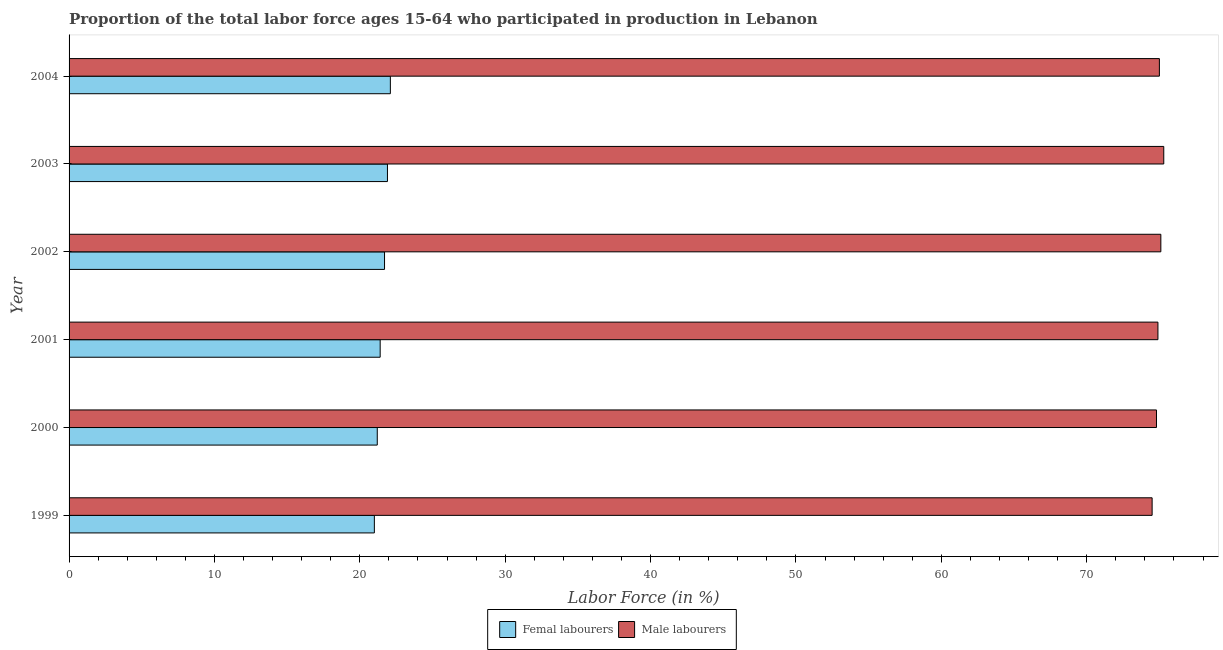How many different coloured bars are there?
Offer a very short reply. 2. How many groups of bars are there?
Give a very brief answer. 6. Are the number of bars on each tick of the Y-axis equal?
Keep it short and to the point. Yes. What is the label of the 6th group of bars from the top?
Make the answer very short. 1999. What is the percentage of female labor force in 2002?
Make the answer very short. 21.7. Across all years, what is the maximum percentage of male labour force?
Your answer should be compact. 75.3. Across all years, what is the minimum percentage of male labour force?
Give a very brief answer. 74.5. What is the total percentage of female labor force in the graph?
Your answer should be very brief. 129.3. What is the difference between the percentage of female labor force in 1999 and that in 2001?
Your answer should be compact. -0.4. What is the difference between the percentage of male labour force in 2000 and the percentage of female labor force in 2003?
Give a very brief answer. 52.9. What is the average percentage of female labor force per year?
Provide a short and direct response. 21.55. In the year 2002, what is the difference between the percentage of female labor force and percentage of male labour force?
Make the answer very short. -53.4. In how many years, is the percentage of female labor force greater than 74 %?
Offer a very short reply. 0. What is the ratio of the percentage of male labour force in 1999 to that in 2002?
Your answer should be compact. 0.99. What is the difference between the highest and the lowest percentage of male labour force?
Give a very brief answer. 0.8. What does the 2nd bar from the top in 2001 represents?
Provide a short and direct response. Femal labourers. What does the 2nd bar from the bottom in 2003 represents?
Offer a terse response. Male labourers. How many bars are there?
Your answer should be compact. 12. Are all the bars in the graph horizontal?
Ensure brevity in your answer.  Yes. How many years are there in the graph?
Ensure brevity in your answer.  6. Are the values on the major ticks of X-axis written in scientific E-notation?
Make the answer very short. No. Does the graph contain any zero values?
Make the answer very short. No. Does the graph contain grids?
Offer a very short reply. No. How are the legend labels stacked?
Give a very brief answer. Horizontal. What is the title of the graph?
Provide a succinct answer. Proportion of the total labor force ages 15-64 who participated in production in Lebanon. Does "Investment in Transport" appear as one of the legend labels in the graph?
Your answer should be very brief. No. What is the label or title of the X-axis?
Keep it short and to the point. Labor Force (in %). What is the label or title of the Y-axis?
Your answer should be compact. Year. What is the Labor Force (in %) in Femal labourers in 1999?
Your answer should be compact. 21. What is the Labor Force (in %) of Male labourers in 1999?
Make the answer very short. 74.5. What is the Labor Force (in %) in Femal labourers in 2000?
Provide a short and direct response. 21.2. What is the Labor Force (in %) of Male labourers in 2000?
Ensure brevity in your answer.  74.8. What is the Labor Force (in %) in Femal labourers in 2001?
Offer a very short reply. 21.4. What is the Labor Force (in %) of Male labourers in 2001?
Make the answer very short. 74.9. What is the Labor Force (in %) in Femal labourers in 2002?
Your answer should be very brief. 21.7. What is the Labor Force (in %) of Male labourers in 2002?
Your answer should be very brief. 75.1. What is the Labor Force (in %) of Femal labourers in 2003?
Give a very brief answer. 21.9. What is the Labor Force (in %) of Male labourers in 2003?
Your answer should be compact. 75.3. What is the Labor Force (in %) of Femal labourers in 2004?
Provide a short and direct response. 22.1. Across all years, what is the maximum Labor Force (in %) in Femal labourers?
Keep it short and to the point. 22.1. Across all years, what is the maximum Labor Force (in %) of Male labourers?
Give a very brief answer. 75.3. Across all years, what is the minimum Labor Force (in %) in Femal labourers?
Your answer should be very brief. 21. Across all years, what is the minimum Labor Force (in %) in Male labourers?
Provide a succinct answer. 74.5. What is the total Labor Force (in %) in Femal labourers in the graph?
Your answer should be compact. 129.3. What is the total Labor Force (in %) of Male labourers in the graph?
Offer a terse response. 449.6. What is the difference between the Labor Force (in %) in Male labourers in 1999 and that in 2000?
Provide a succinct answer. -0.3. What is the difference between the Labor Force (in %) in Femal labourers in 1999 and that in 2001?
Provide a succinct answer. -0.4. What is the difference between the Labor Force (in %) in Male labourers in 1999 and that in 2001?
Offer a terse response. -0.4. What is the difference between the Labor Force (in %) in Male labourers in 1999 and that in 2002?
Make the answer very short. -0.6. What is the difference between the Labor Force (in %) in Femal labourers in 1999 and that in 2003?
Give a very brief answer. -0.9. What is the difference between the Labor Force (in %) in Femal labourers in 1999 and that in 2004?
Your answer should be compact. -1.1. What is the difference between the Labor Force (in %) in Male labourers in 2000 and that in 2001?
Keep it short and to the point. -0.1. What is the difference between the Labor Force (in %) of Femal labourers in 2000 and that in 2002?
Ensure brevity in your answer.  -0.5. What is the difference between the Labor Force (in %) of Male labourers in 2000 and that in 2002?
Provide a succinct answer. -0.3. What is the difference between the Labor Force (in %) in Femal labourers in 2000 and that in 2004?
Your answer should be compact. -0.9. What is the difference between the Labor Force (in %) of Male labourers in 2000 and that in 2004?
Provide a succinct answer. -0.2. What is the difference between the Labor Force (in %) of Male labourers in 2001 and that in 2002?
Provide a short and direct response. -0.2. What is the difference between the Labor Force (in %) in Male labourers in 2001 and that in 2003?
Provide a short and direct response. -0.4. What is the difference between the Labor Force (in %) in Male labourers in 2001 and that in 2004?
Keep it short and to the point. -0.1. What is the difference between the Labor Force (in %) of Male labourers in 2002 and that in 2003?
Keep it short and to the point. -0.2. What is the difference between the Labor Force (in %) in Femal labourers in 2002 and that in 2004?
Your answer should be compact. -0.4. What is the difference between the Labor Force (in %) of Male labourers in 2002 and that in 2004?
Give a very brief answer. 0.1. What is the difference between the Labor Force (in %) of Male labourers in 2003 and that in 2004?
Provide a succinct answer. 0.3. What is the difference between the Labor Force (in %) in Femal labourers in 1999 and the Labor Force (in %) in Male labourers in 2000?
Provide a succinct answer. -53.8. What is the difference between the Labor Force (in %) of Femal labourers in 1999 and the Labor Force (in %) of Male labourers in 2001?
Provide a short and direct response. -53.9. What is the difference between the Labor Force (in %) in Femal labourers in 1999 and the Labor Force (in %) in Male labourers in 2002?
Provide a succinct answer. -54.1. What is the difference between the Labor Force (in %) in Femal labourers in 1999 and the Labor Force (in %) in Male labourers in 2003?
Offer a very short reply. -54.3. What is the difference between the Labor Force (in %) in Femal labourers in 1999 and the Labor Force (in %) in Male labourers in 2004?
Provide a short and direct response. -54. What is the difference between the Labor Force (in %) in Femal labourers in 2000 and the Labor Force (in %) in Male labourers in 2001?
Provide a succinct answer. -53.7. What is the difference between the Labor Force (in %) of Femal labourers in 2000 and the Labor Force (in %) of Male labourers in 2002?
Your answer should be very brief. -53.9. What is the difference between the Labor Force (in %) in Femal labourers in 2000 and the Labor Force (in %) in Male labourers in 2003?
Keep it short and to the point. -54.1. What is the difference between the Labor Force (in %) in Femal labourers in 2000 and the Labor Force (in %) in Male labourers in 2004?
Offer a terse response. -53.8. What is the difference between the Labor Force (in %) of Femal labourers in 2001 and the Labor Force (in %) of Male labourers in 2002?
Your response must be concise. -53.7. What is the difference between the Labor Force (in %) of Femal labourers in 2001 and the Labor Force (in %) of Male labourers in 2003?
Make the answer very short. -53.9. What is the difference between the Labor Force (in %) of Femal labourers in 2001 and the Labor Force (in %) of Male labourers in 2004?
Provide a short and direct response. -53.6. What is the difference between the Labor Force (in %) of Femal labourers in 2002 and the Labor Force (in %) of Male labourers in 2003?
Offer a very short reply. -53.6. What is the difference between the Labor Force (in %) of Femal labourers in 2002 and the Labor Force (in %) of Male labourers in 2004?
Keep it short and to the point. -53.3. What is the difference between the Labor Force (in %) of Femal labourers in 2003 and the Labor Force (in %) of Male labourers in 2004?
Your answer should be very brief. -53.1. What is the average Labor Force (in %) of Femal labourers per year?
Your answer should be very brief. 21.55. What is the average Labor Force (in %) in Male labourers per year?
Your response must be concise. 74.93. In the year 1999, what is the difference between the Labor Force (in %) in Femal labourers and Labor Force (in %) in Male labourers?
Offer a terse response. -53.5. In the year 2000, what is the difference between the Labor Force (in %) in Femal labourers and Labor Force (in %) in Male labourers?
Your response must be concise. -53.6. In the year 2001, what is the difference between the Labor Force (in %) of Femal labourers and Labor Force (in %) of Male labourers?
Ensure brevity in your answer.  -53.5. In the year 2002, what is the difference between the Labor Force (in %) of Femal labourers and Labor Force (in %) of Male labourers?
Provide a short and direct response. -53.4. In the year 2003, what is the difference between the Labor Force (in %) in Femal labourers and Labor Force (in %) in Male labourers?
Offer a very short reply. -53.4. In the year 2004, what is the difference between the Labor Force (in %) of Femal labourers and Labor Force (in %) of Male labourers?
Ensure brevity in your answer.  -52.9. What is the ratio of the Labor Force (in %) in Femal labourers in 1999 to that in 2000?
Provide a short and direct response. 0.99. What is the ratio of the Labor Force (in %) in Femal labourers in 1999 to that in 2001?
Give a very brief answer. 0.98. What is the ratio of the Labor Force (in %) in Male labourers in 1999 to that in 2001?
Make the answer very short. 0.99. What is the ratio of the Labor Force (in %) of Femal labourers in 1999 to that in 2002?
Provide a succinct answer. 0.97. What is the ratio of the Labor Force (in %) of Male labourers in 1999 to that in 2002?
Make the answer very short. 0.99. What is the ratio of the Labor Force (in %) of Femal labourers in 1999 to that in 2003?
Offer a very short reply. 0.96. What is the ratio of the Labor Force (in %) of Male labourers in 1999 to that in 2003?
Your answer should be very brief. 0.99. What is the ratio of the Labor Force (in %) in Femal labourers in 1999 to that in 2004?
Give a very brief answer. 0.95. What is the ratio of the Labor Force (in %) of Male labourers in 1999 to that in 2004?
Your answer should be compact. 0.99. What is the ratio of the Labor Force (in %) in Male labourers in 2000 to that in 2001?
Keep it short and to the point. 1. What is the ratio of the Labor Force (in %) of Femal labourers in 2000 to that in 2002?
Make the answer very short. 0.98. What is the ratio of the Labor Force (in %) in Male labourers in 2000 to that in 2002?
Ensure brevity in your answer.  1. What is the ratio of the Labor Force (in %) of Male labourers in 2000 to that in 2003?
Provide a short and direct response. 0.99. What is the ratio of the Labor Force (in %) of Femal labourers in 2000 to that in 2004?
Your response must be concise. 0.96. What is the ratio of the Labor Force (in %) in Femal labourers in 2001 to that in 2002?
Offer a terse response. 0.99. What is the ratio of the Labor Force (in %) in Male labourers in 2001 to that in 2002?
Provide a short and direct response. 1. What is the ratio of the Labor Force (in %) in Femal labourers in 2001 to that in 2003?
Provide a short and direct response. 0.98. What is the ratio of the Labor Force (in %) of Femal labourers in 2001 to that in 2004?
Offer a very short reply. 0.97. What is the ratio of the Labor Force (in %) of Male labourers in 2001 to that in 2004?
Give a very brief answer. 1. What is the ratio of the Labor Force (in %) of Femal labourers in 2002 to that in 2003?
Offer a terse response. 0.99. What is the ratio of the Labor Force (in %) in Male labourers in 2002 to that in 2003?
Provide a short and direct response. 1. What is the ratio of the Labor Force (in %) in Femal labourers in 2002 to that in 2004?
Your answer should be very brief. 0.98. What is the difference between the highest and the lowest Labor Force (in %) of Femal labourers?
Provide a succinct answer. 1.1. What is the difference between the highest and the lowest Labor Force (in %) of Male labourers?
Your answer should be compact. 0.8. 